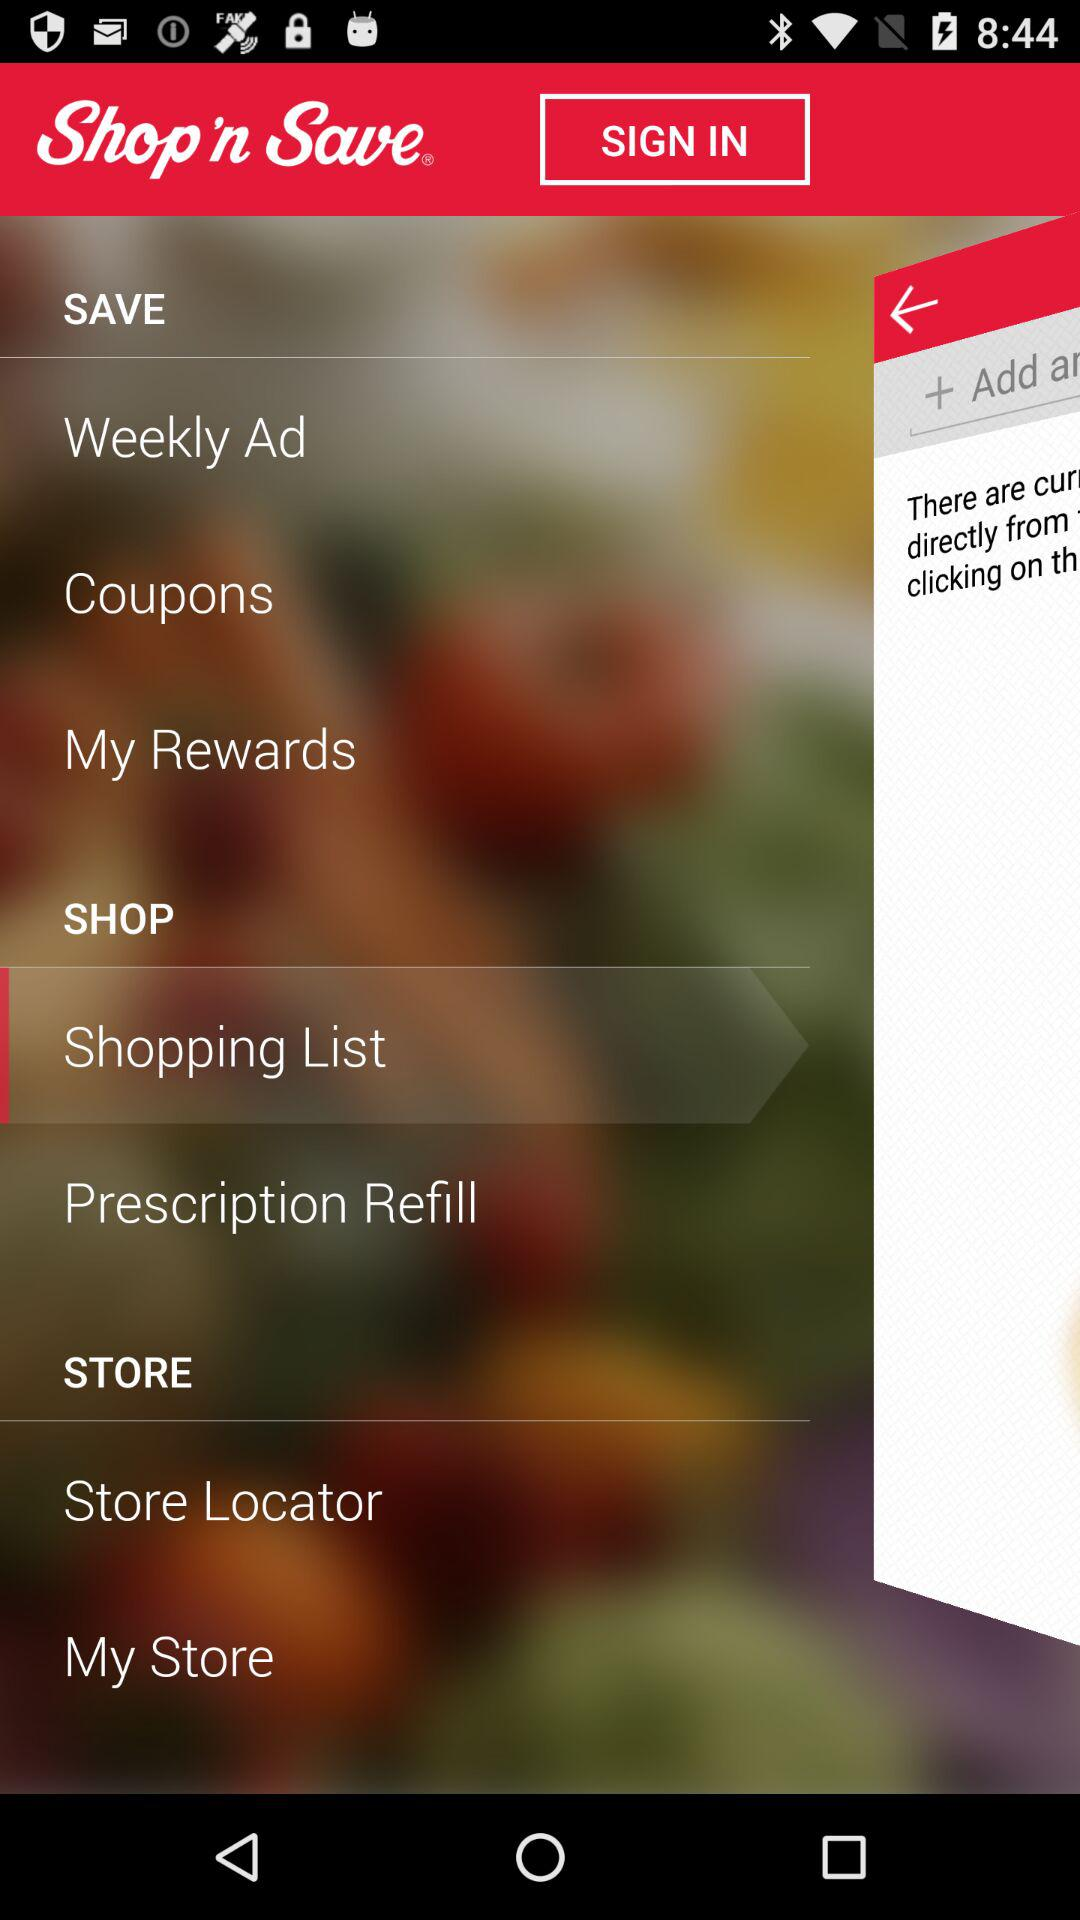What is the application name? The application name is "Shop 'n Save". 